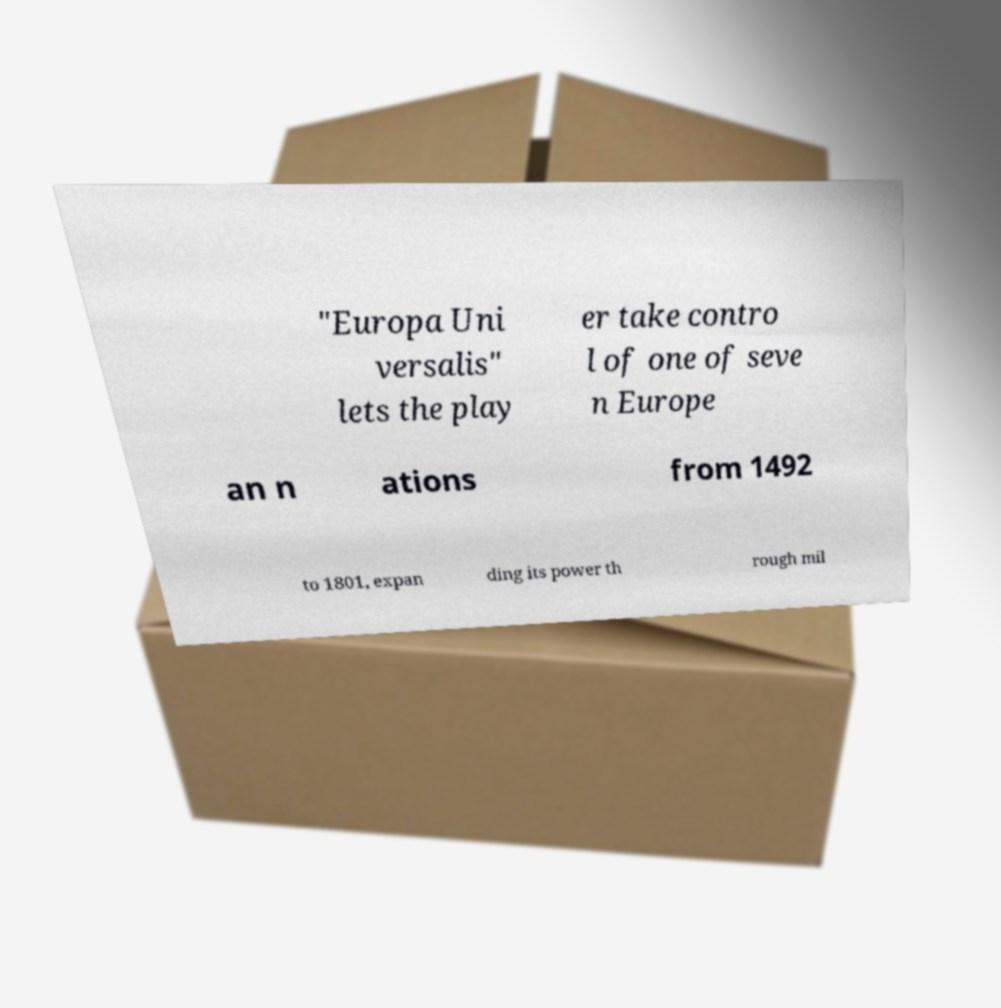Could you assist in decoding the text presented in this image and type it out clearly? "Europa Uni versalis" lets the play er take contro l of one of seve n Europe an n ations from 1492 to 1801, expan ding its power th rough mil 